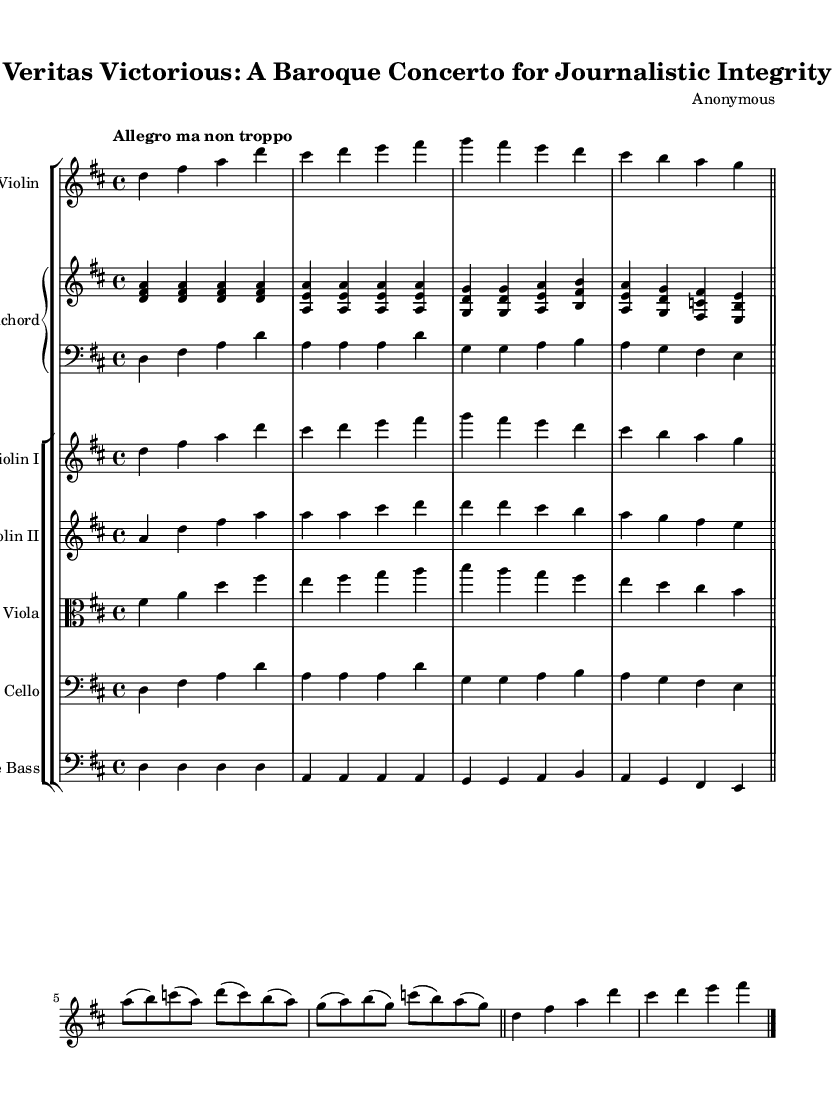What is the key signature of this music? The key signature is indicated at the beginning of the staff, showing two sharps (F# and C#), which defines the piece as D major.
Answer: D major What is the time signature of this music? The time signature is displayed at the beginning of the score, specified as 4/4, meaning there are four beats per measure and the quarter note receives one beat.
Answer: 4/4 What is the tempo marking of the piece? The tempo marking is located at the start of the score, written as "Allegro ma non troppo," indicating a fast tempo, but with a suggestion not to play too quickly.
Answer: Allegro ma non troppo Which instruments are included in the concerto? The instruments are listed by their names at the start of each staff. They include Solo Violin, Harpsichord, Violin I, Violin II, Viola, Cello, and Double Bass.
Answer: Solo Violin, Harpsichord, Violin I, Violin II, Viola, Cello, Double Bass What type of musical form does this piece utilize? By examining the structure of the music, which includes a ritornello and solo episodes characteristic of Baroque concertos, it reveals that the piece employs a concerto form.
Answer: Concerto form How many measures are there in the solo episode? The solo episode consists of 8 measures, with each measure clearly demarcated by vertical lines. Counting the measures yields a total of eight.
Answer: 8 measures In which period of music history does this concerto belong? Observing the style, instrumentation, and its title referencing journalistic integrity, it is evident that this piece belongs to the Baroque period, recognized for its ornamentation and formal styles.
Answer: Baroque 